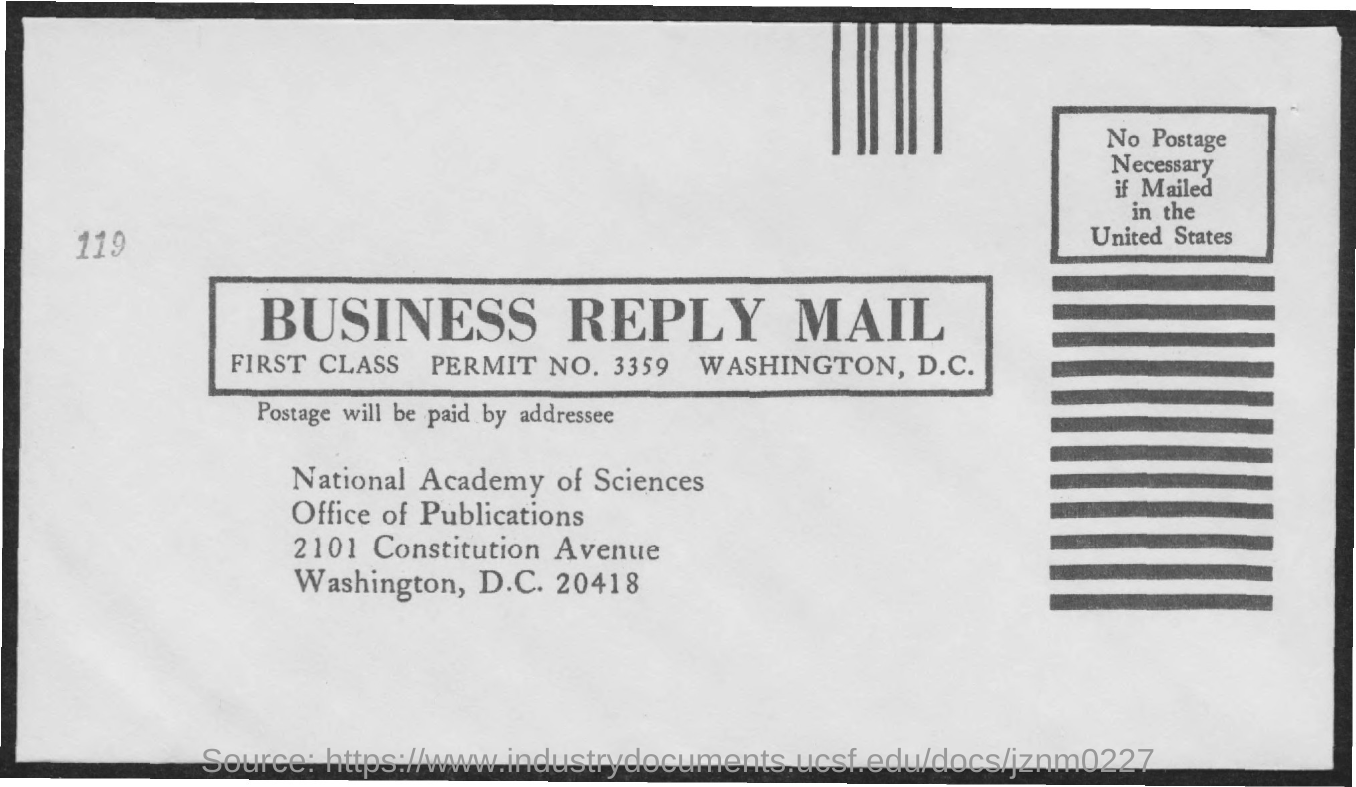Highlight a few significant elements in this photo. The type of class mentioned is first class. The permit number mentioned is 3359. 